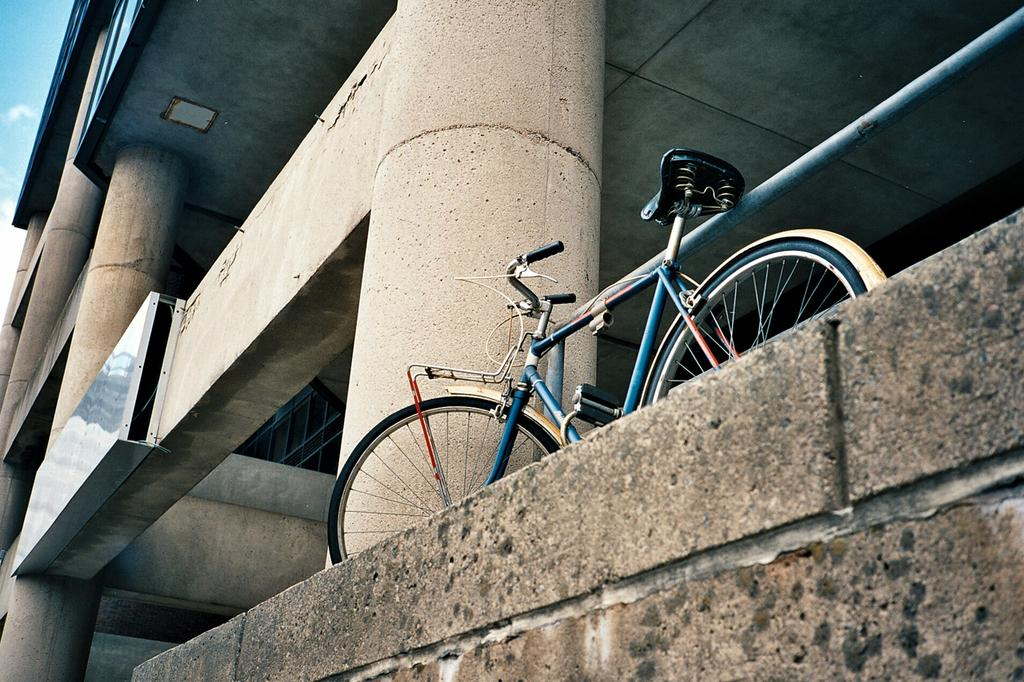What object is located on the surface in the image? There is a bicycle on the surface in the image. What type of structure can be seen in the image? There is a wall in the image. What architectural features are present in the image? There are pillars and a rod in the image. What is attached to the wall in the image? There is a board on a wall in the image. What is visible in the background of the image? The sky is visible in the image. What type of government event is taking place in the image? There is no indication of a government event or any event in the image; it features a bicycle, a wall, pillars, a rod, a board, and the sky. Can you tell me how many times the person in the image bites the rod? There is no person present in the image, and therefore no biting activity can be observed. 